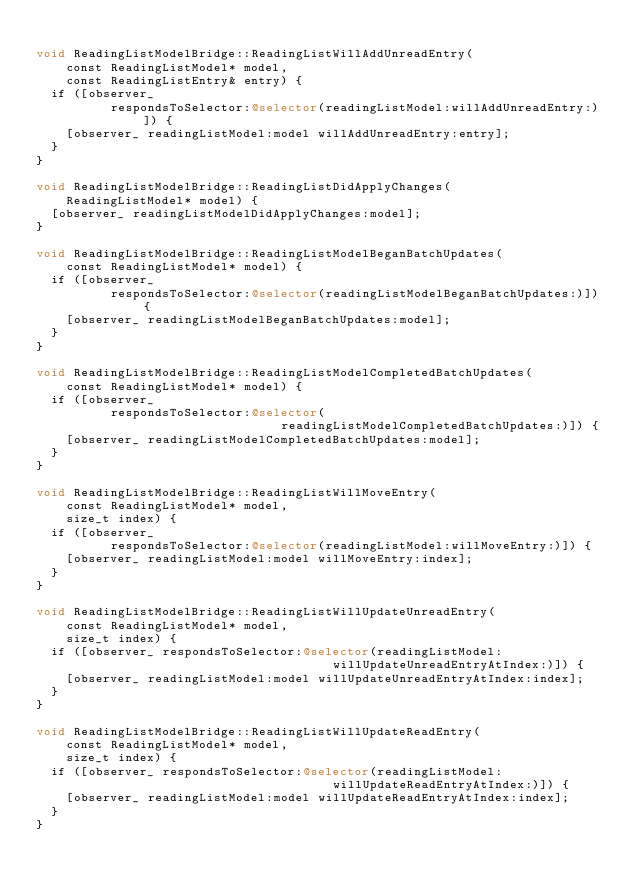Convert code to text. <code><loc_0><loc_0><loc_500><loc_500><_ObjectiveC_>
void ReadingListModelBridge::ReadingListWillAddUnreadEntry(
    const ReadingListModel* model,
    const ReadingListEntry& entry) {
  if ([observer_
          respondsToSelector:@selector(readingListModel:willAddUnreadEntry:)]) {
    [observer_ readingListModel:model willAddUnreadEntry:entry];
  }
}

void ReadingListModelBridge::ReadingListDidApplyChanges(
    ReadingListModel* model) {
  [observer_ readingListModelDidApplyChanges:model];
}

void ReadingListModelBridge::ReadingListModelBeganBatchUpdates(
    const ReadingListModel* model) {
  if ([observer_
          respondsToSelector:@selector(readingListModelBeganBatchUpdates:)]) {
    [observer_ readingListModelBeganBatchUpdates:model];
  }
}

void ReadingListModelBridge::ReadingListModelCompletedBatchUpdates(
    const ReadingListModel* model) {
  if ([observer_
          respondsToSelector:@selector(
                                 readingListModelCompletedBatchUpdates:)]) {
    [observer_ readingListModelCompletedBatchUpdates:model];
  }
}

void ReadingListModelBridge::ReadingListWillMoveEntry(
    const ReadingListModel* model,
    size_t index) {
  if ([observer_
          respondsToSelector:@selector(readingListModel:willMoveEntry:)]) {
    [observer_ readingListModel:model willMoveEntry:index];
  }
}

void ReadingListModelBridge::ReadingListWillUpdateUnreadEntry(
    const ReadingListModel* model,
    size_t index) {
  if ([observer_ respondsToSelector:@selector(readingListModel:
                                        willUpdateUnreadEntryAtIndex:)]) {
    [observer_ readingListModel:model willUpdateUnreadEntryAtIndex:index];
  }
}

void ReadingListModelBridge::ReadingListWillUpdateReadEntry(
    const ReadingListModel* model,
    size_t index) {
  if ([observer_ respondsToSelector:@selector(readingListModel:
                                        willUpdateReadEntryAtIndex:)]) {
    [observer_ readingListModel:model willUpdateReadEntryAtIndex:index];
  }
}
</code> 